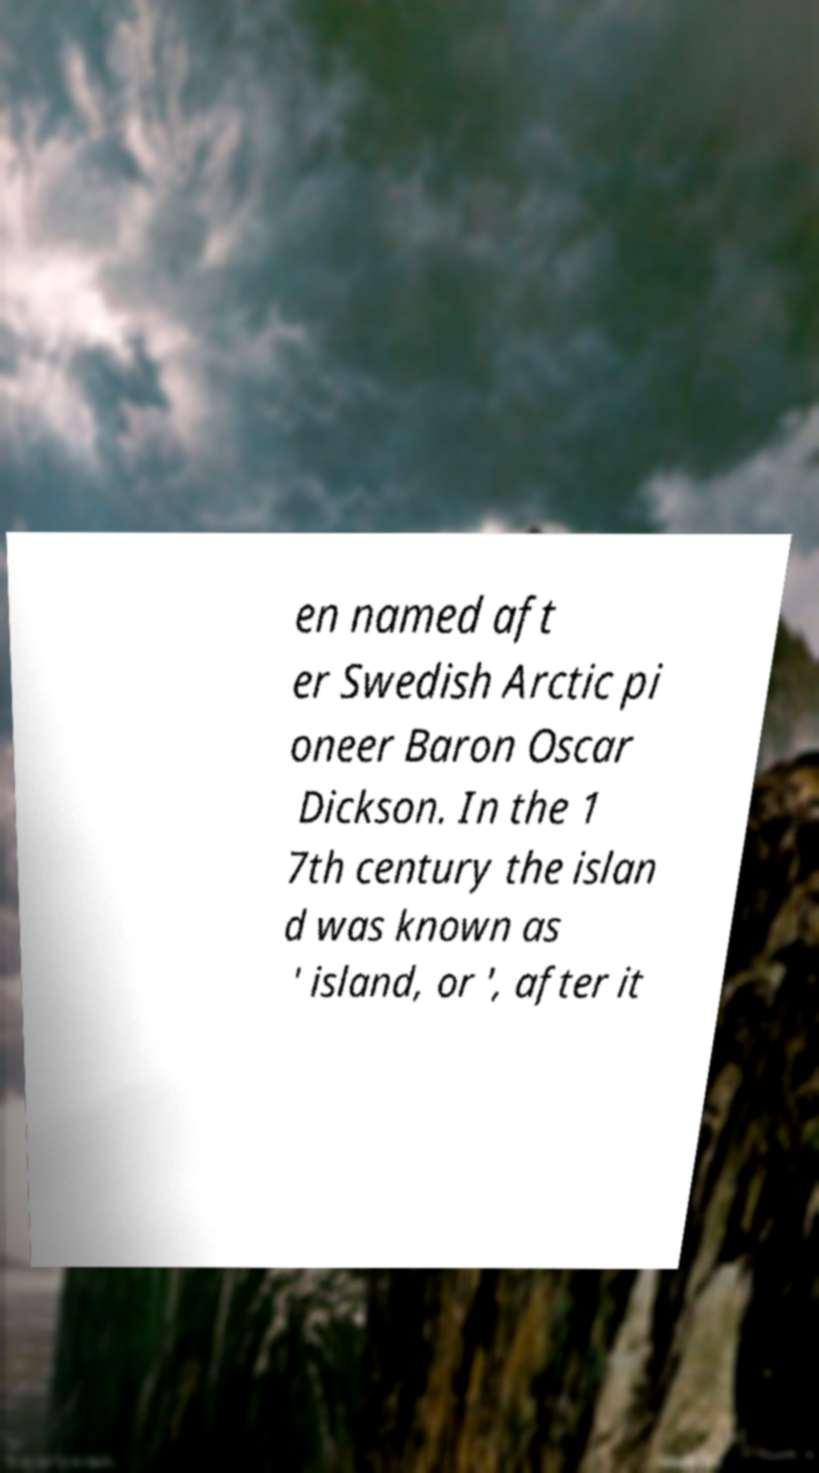Please identify and transcribe the text found in this image. en named aft er Swedish Arctic pi oneer Baron Oscar Dickson. In the 1 7th century the islan d was known as ' island, or ', after it 